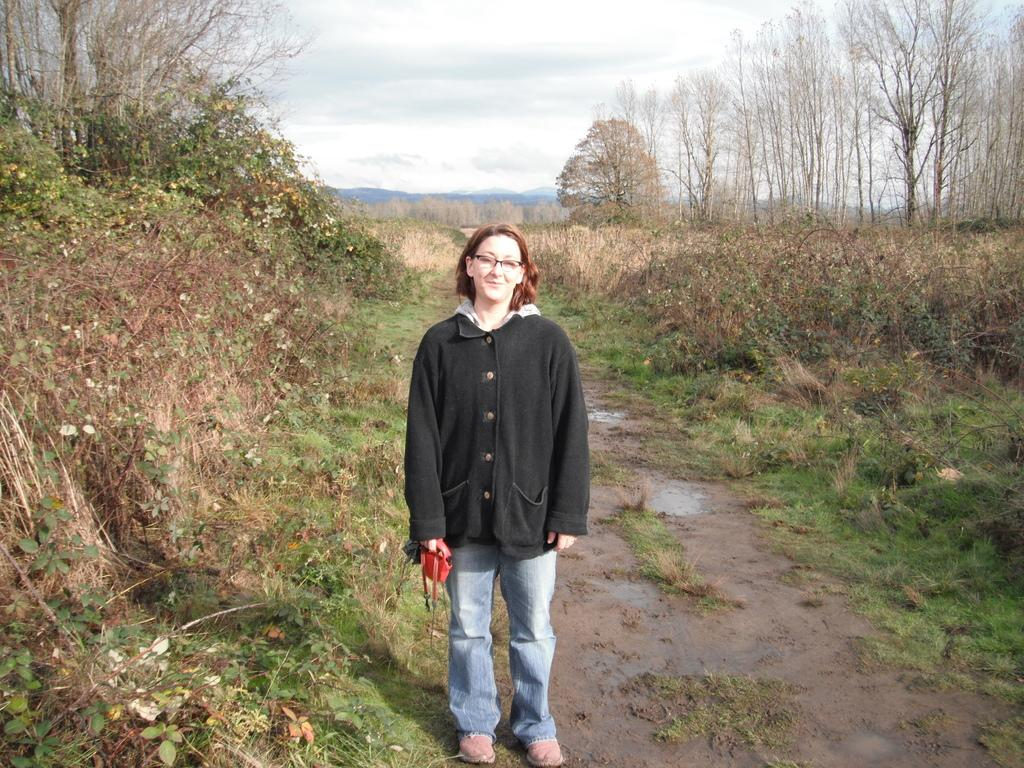What is the main subject of the image? The main subject of the image is a woman. What is the woman doing in the image? The woman is standing and smiling in the image. What is the woman holding in the image? The woman is holding a bag in the image. What type of natural environment can be seen in the image? The image features plants, grass, mud, trees, hills, and the sky. What type of stew is being prepared in the image? There is no stew present in the image; it features a woman standing and smiling, holding a bag, and surrounded by a natural environment. Who is the owner of the plants in the image? There is no indication of ownership in the image, as it only shows a woman and the natural environment. 